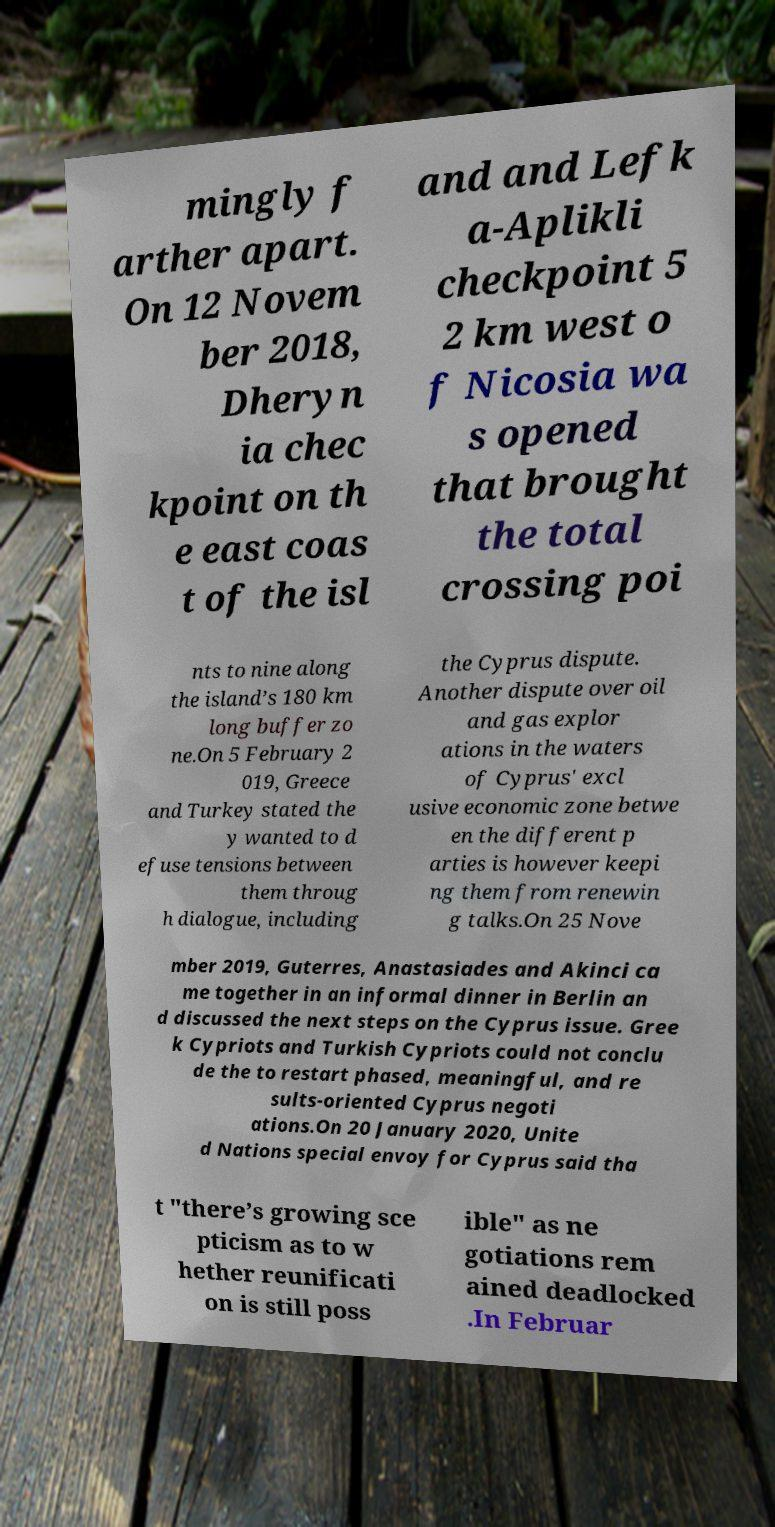Can you read and provide the text displayed in the image?This photo seems to have some interesting text. Can you extract and type it out for me? mingly f arther apart. On 12 Novem ber 2018, Dheryn ia chec kpoint on th e east coas t of the isl and and Lefk a-Aplikli checkpoint 5 2 km west o f Nicosia wa s opened that brought the total crossing poi nts to nine along the island’s 180 km long buffer zo ne.On 5 February 2 019, Greece and Turkey stated the y wanted to d efuse tensions between them throug h dialogue, including the Cyprus dispute. Another dispute over oil and gas explor ations in the waters of Cyprus' excl usive economic zone betwe en the different p arties is however keepi ng them from renewin g talks.On 25 Nove mber 2019, Guterres, Anastasiades and Akinci ca me together in an informal dinner in Berlin an d discussed the next steps on the Cyprus issue. Gree k Cypriots and Turkish Cypriots could not conclu de the to restart phased, meaningful, and re sults-oriented Cyprus negoti ations.On 20 January 2020, Unite d Nations special envoy for Cyprus said tha t "there’s growing sce pticism as to w hether reunificati on is still poss ible" as ne gotiations rem ained deadlocked .In Februar 